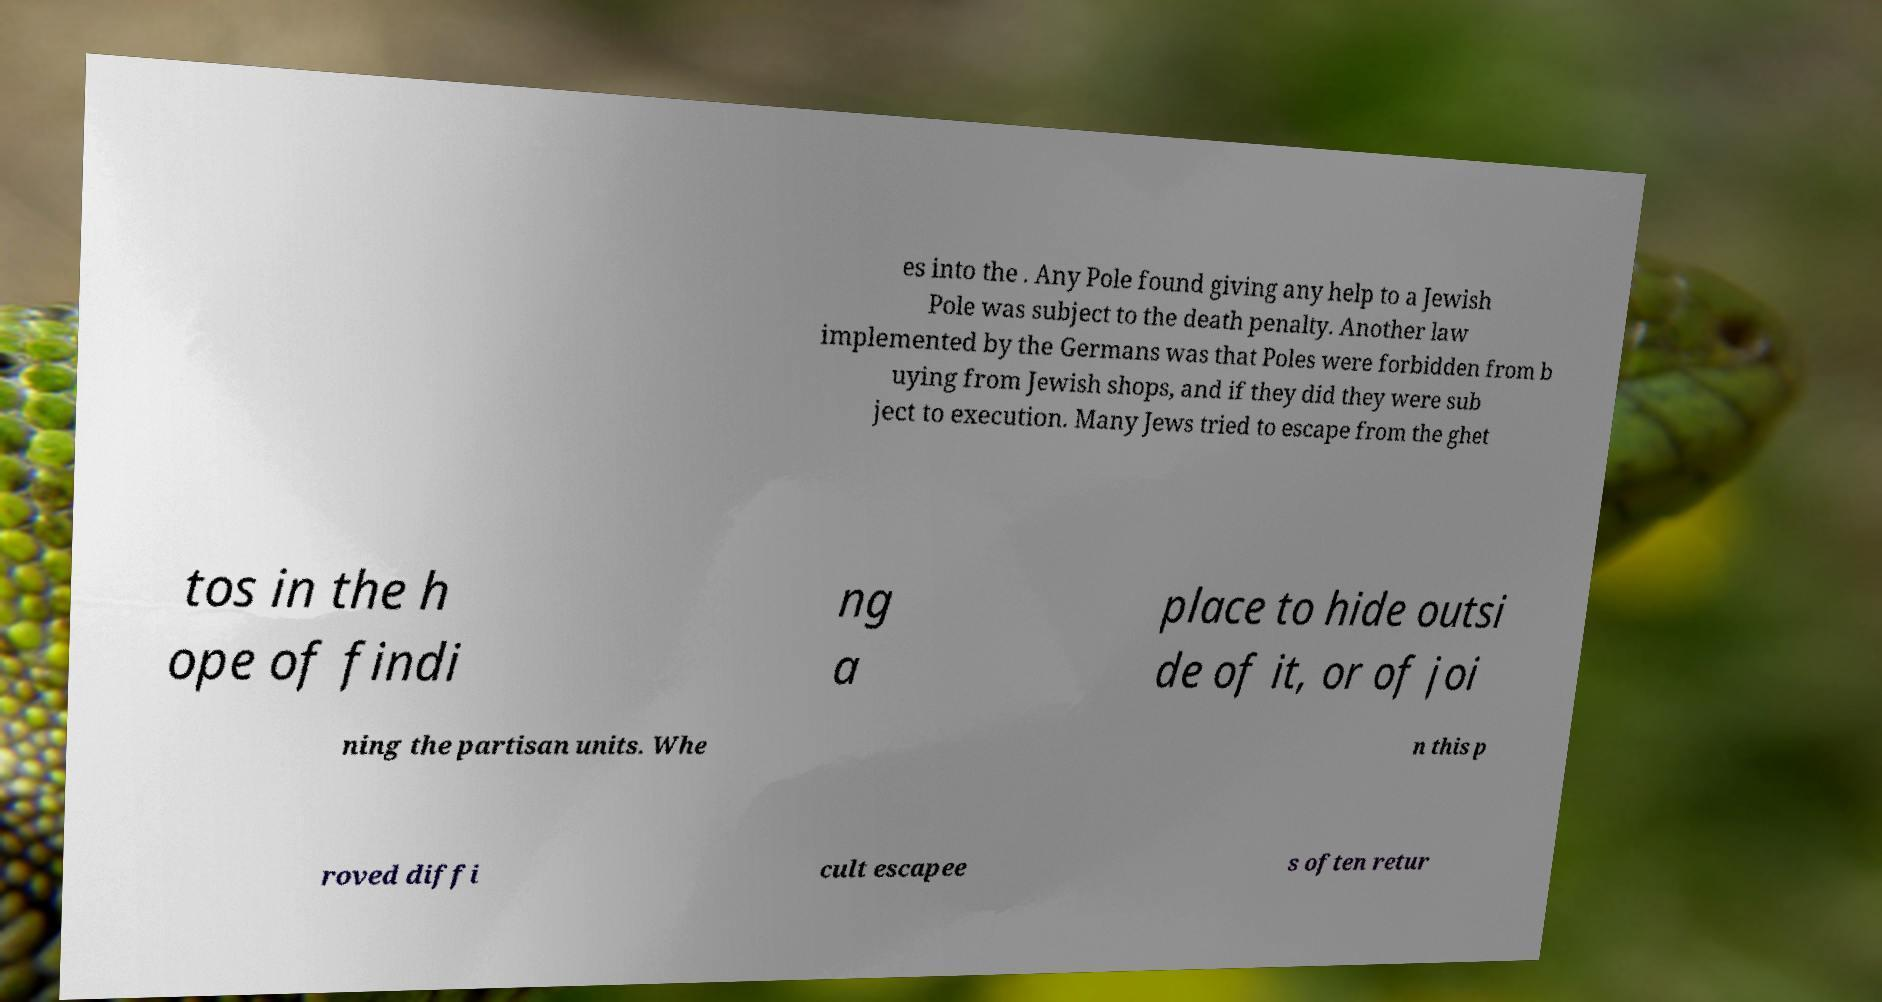Can you accurately transcribe the text from the provided image for me? es into the . Any Pole found giving any help to a Jewish Pole was subject to the death penalty. Another law implemented by the Germans was that Poles were forbidden from b uying from Jewish shops, and if they did they were sub ject to execution. Many Jews tried to escape from the ghet tos in the h ope of findi ng a place to hide outsi de of it, or of joi ning the partisan units. Whe n this p roved diffi cult escapee s often retur 